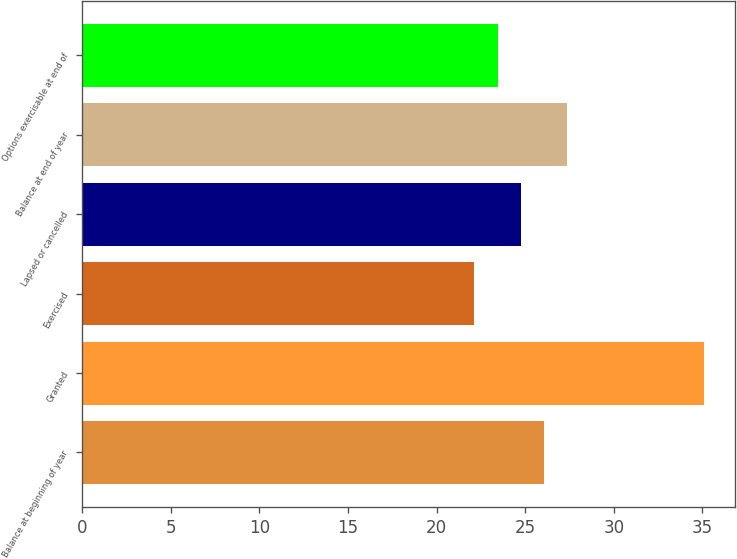Convert chart. <chart><loc_0><loc_0><loc_500><loc_500><bar_chart><fcel>Balance at beginning of year<fcel>Granted<fcel>Exercised<fcel>Lapsed or cancelled<fcel>Balance at end of year<fcel>Options exercisable at end of<nl><fcel>26.04<fcel>35.09<fcel>22.14<fcel>24.74<fcel>27.34<fcel>23.44<nl></chart> 